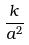Convert formula to latex. <formula><loc_0><loc_0><loc_500><loc_500>\frac { k } { a ^ { 2 } }</formula> 